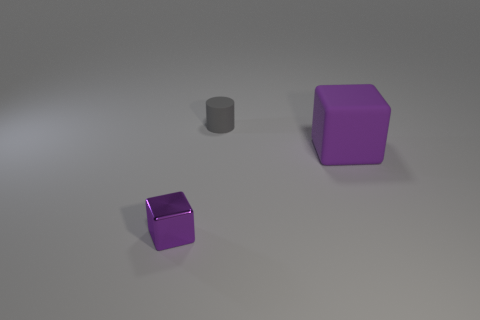Add 3 small shiny objects. How many objects exist? 6 Subtract all cylinders. How many objects are left? 2 Subtract 0 yellow cubes. How many objects are left? 3 Subtract all tiny cylinders. Subtract all tiny purple cubes. How many objects are left? 1 Add 3 big things. How many big things are left? 4 Add 2 tiny gray objects. How many tiny gray objects exist? 3 